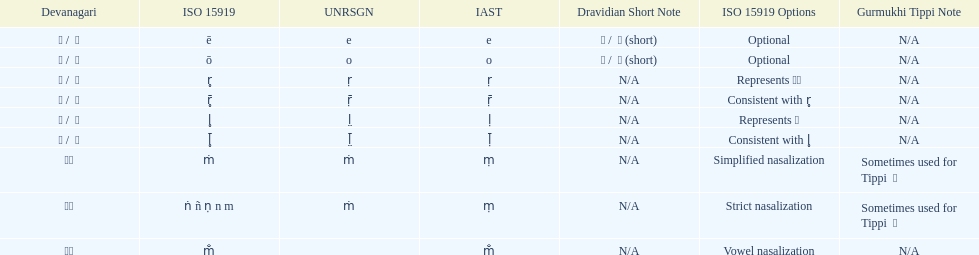Which devanagari transliteration is listed on the top of the table? ए / े. 